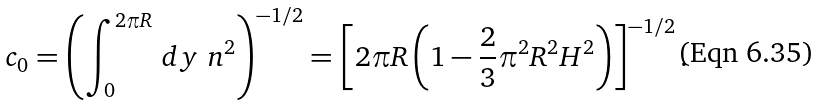<formula> <loc_0><loc_0><loc_500><loc_500>c _ { 0 } = \left ( \int _ { 0 } ^ { 2 \pi R } \, d y \ n ^ { 2 } \right ) ^ { - 1 / 2 } = \left [ 2 \pi R \left ( 1 - \frac { 2 } { 3 } \pi ^ { 2 } R ^ { 2 } H ^ { 2 } \right ) \right ] ^ { - 1 / 2 } .</formula> 